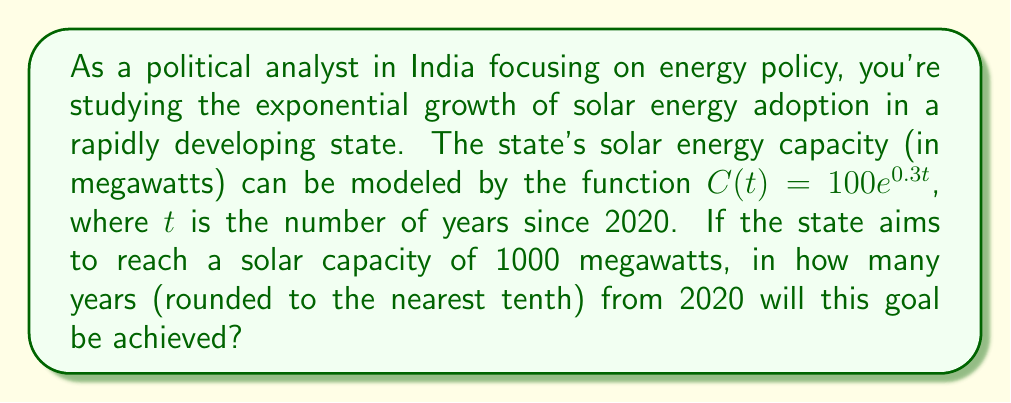Provide a solution to this math problem. To solve this problem, we need to use the exponential growth model and solve for $t$. Let's approach this step-by-step:

1) We're given the exponential growth function: $C(t) = 100e^{0.3t}$

2) We want to find $t$ when $C(t) = 1000$ megawatts. So, we set up the equation:

   $1000 = 100e^{0.3t}$

3) Divide both sides by 100:

   $10 = e^{0.3t}$

4) Take the natural logarithm of both sides:

   $\ln(10) = \ln(e^{0.3t})$

5) Simplify the right side using the logarithm property $\ln(e^x) = x$:

   $\ln(10) = 0.3t$

6) Solve for $t$ by dividing both sides by 0.3:

   $t = \frac{\ln(10)}{0.3}$

7) Calculate this value:

   $t = \frac{\ln(10)}{0.3} \approx 7.675$ years

8) Rounding to the nearest tenth:

   $t \approx 7.7$ years

Therefore, it will take approximately 7.7 years from 2020 for the state to reach its goal of 1000 megawatts of solar capacity.
Answer: 7.7 years 